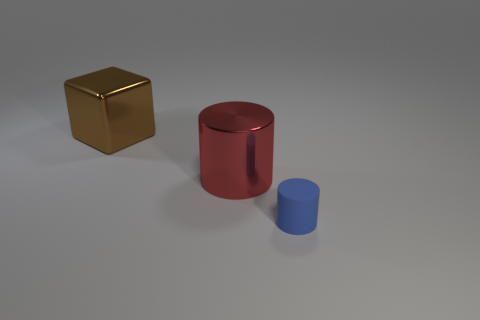What is the shape of the metallic object on the left side of the cylinder that is to the left of the tiny blue thing?
Your answer should be compact. Cube. Are there fewer big green objects than large brown metal objects?
Keep it short and to the point. Yes. Is the material of the small thing the same as the large red object?
Offer a terse response. No. There is a object that is to the left of the blue rubber thing and right of the brown cube; what color is it?
Give a very brief answer. Red. Is there a metal cylinder of the same size as the brown thing?
Offer a very short reply. Yes. What is the size of the shiny object behind the big thing right of the large shiny cube?
Make the answer very short. Large. Is the number of large cylinders left of the red metallic object less than the number of brown metal cylinders?
Offer a very short reply. No. Does the tiny rubber thing have the same color as the large metal cube?
Provide a succinct answer. No. How big is the brown object?
Ensure brevity in your answer.  Large. There is a cylinder to the left of the small blue matte thing in front of the large brown metal object; are there any red metallic cylinders in front of it?
Make the answer very short. No. 